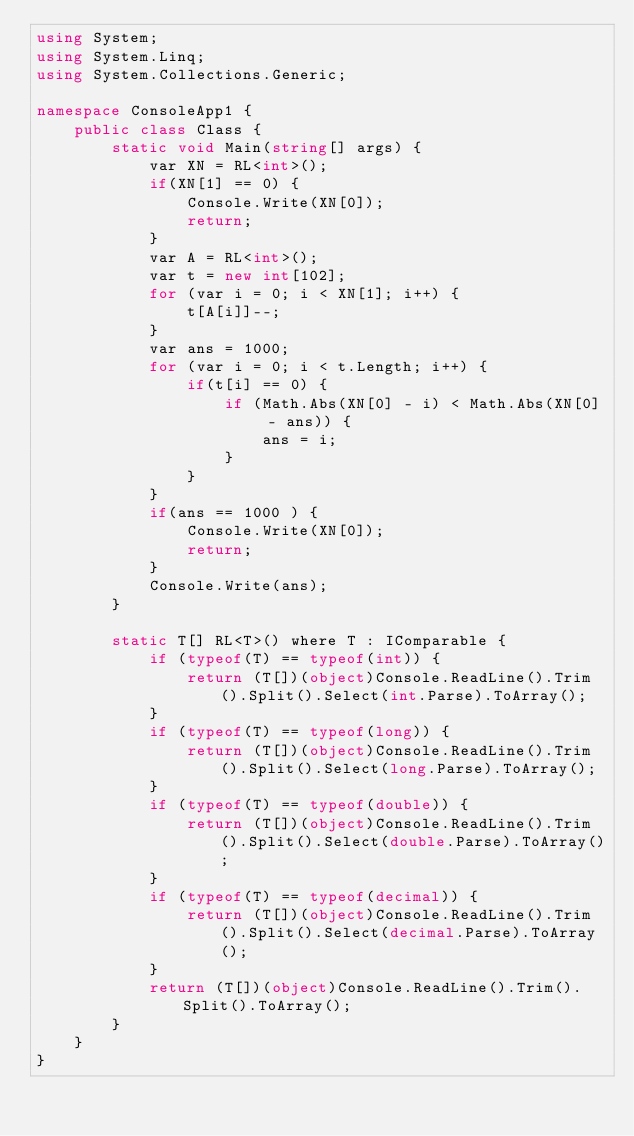Convert code to text. <code><loc_0><loc_0><loc_500><loc_500><_C#_>using System;
using System.Linq;
using System.Collections.Generic;

namespace ConsoleApp1 {
    public class Class {
        static void Main(string[] args) {
            var XN = RL<int>();
            if(XN[1] == 0) {
                Console.Write(XN[0]);
                return;
            }
            var A = RL<int>();
            var t = new int[102];
            for (var i = 0; i < XN[1]; i++) {
                t[A[i]]--; 
            }
            var ans = 1000;
            for (var i = 0; i < t.Length; i++) {
                if(t[i] == 0) {
                    if (Math.Abs(XN[0] - i) < Math.Abs(XN[0] - ans)) {
                        ans = i;
                    }
                }
            }
            if(ans == 1000 ) {
                Console.Write(XN[0]);
                return;
            }
            Console.Write(ans);
        }

        static T[] RL<T>() where T : IComparable {
            if (typeof(T) == typeof(int)) {
                return (T[])(object)Console.ReadLine().Trim().Split().Select(int.Parse).ToArray();
            }
            if (typeof(T) == typeof(long)) {
                return (T[])(object)Console.ReadLine().Trim().Split().Select(long.Parse).ToArray();
            }
            if (typeof(T) == typeof(double)) {
                return (T[])(object)Console.ReadLine().Trim().Split().Select(double.Parse).ToArray();
            }
            if (typeof(T) == typeof(decimal)) {
                return (T[])(object)Console.ReadLine().Trim().Split().Select(decimal.Parse).ToArray();
            }
            return (T[])(object)Console.ReadLine().Trim().Split().ToArray();
        }
    }
}</code> 